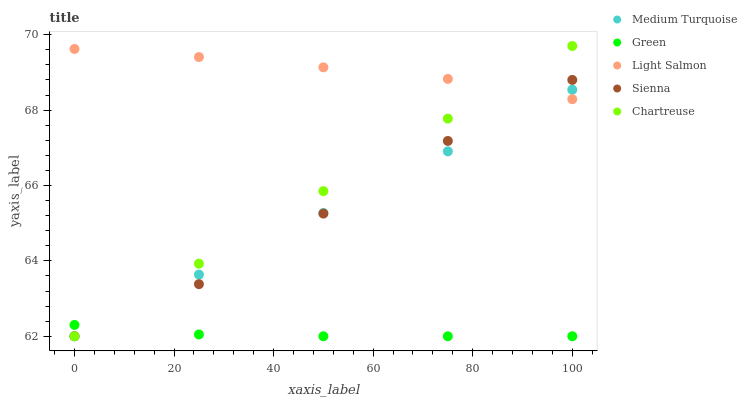Does Green have the minimum area under the curve?
Answer yes or no. Yes. Does Light Salmon have the maximum area under the curve?
Answer yes or no. Yes. Does Light Salmon have the minimum area under the curve?
Answer yes or no. No. Does Green have the maximum area under the curve?
Answer yes or no. No. Is Medium Turquoise the smoothest?
Answer yes or no. Yes. Is Sienna the roughest?
Answer yes or no. Yes. Is Light Salmon the smoothest?
Answer yes or no. No. Is Light Salmon the roughest?
Answer yes or no. No. Does Sienna have the lowest value?
Answer yes or no. Yes. Does Light Salmon have the lowest value?
Answer yes or no. No. Does Chartreuse have the highest value?
Answer yes or no. Yes. Does Light Salmon have the highest value?
Answer yes or no. No. Is Green less than Light Salmon?
Answer yes or no. Yes. Is Light Salmon greater than Green?
Answer yes or no. Yes. Does Sienna intersect Light Salmon?
Answer yes or no. Yes. Is Sienna less than Light Salmon?
Answer yes or no. No. Is Sienna greater than Light Salmon?
Answer yes or no. No. Does Green intersect Light Salmon?
Answer yes or no. No. 